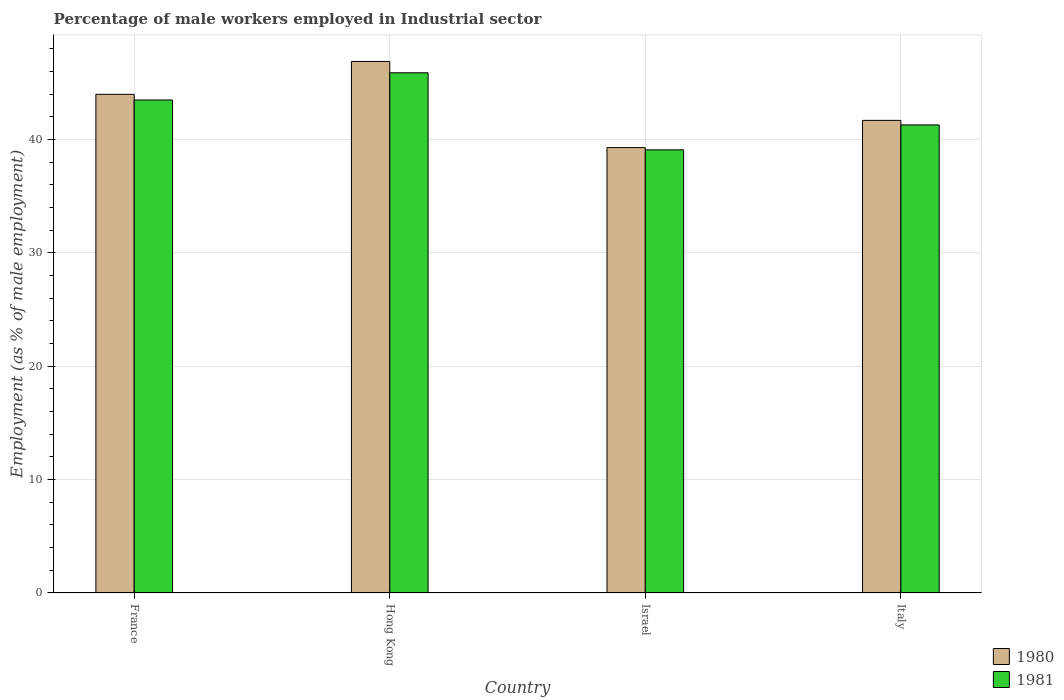How many different coloured bars are there?
Provide a succinct answer. 2. How many groups of bars are there?
Give a very brief answer. 4. Are the number of bars per tick equal to the number of legend labels?
Your response must be concise. Yes. Are the number of bars on each tick of the X-axis equal?
Give a very brief answer. Yes. What is the label of the 4th group of bars from the left?
Give a very brief answer. Italy. What is the percentage of male workers employed in Industrial sector in 1981 in France?
Your response must be concise. 43.5. Across all countries, what is the maximum percentage of male workers employed in Industrial sector in 1980?
Give a very brief answer. 46.9. Across all countries, what is the minimum percentage of male workers employed in Industrial sector in 1981?
Provide a short and direct response. 39.1. In which country was the percentage of male workers employed in Industrial sector in 1980 maximum?
Ensure brevity in your answer.  Hong Kong. In which country was the percentage of male workers employed in Industrial sector in 1981 minimum?
Make the answer very short. Israel. What is the total percentage of male workers employed in Industrial sector in 1981 in the graph?
Give a very brief answer. 169.8. What is the difference between the percentage of male workers employed in Industrial sector in 1980 in France and that in Hong Kong?
Make the answer very short. -2.9. What is the difference between the percentage of male workers employed in Industrial sector in 1980 in France and the percentage of male workers employed in Industrial sector in 1981 in Israel?
Offer a very short reply. 4.9. What is the average percentage of male workers employed in Industrial sector in 1981 per country?
Provide a succinct answer. 42.45. What is the difference between the percentage of male workers employed in Industrial sector of/in 1980 and percentage of male workers employed in Industrial sector of/in 1981 in Italy?
Make the answer very short. 0.4. In how many countries, is the percentage of male workers employed in Industrial sector in 1981 greater than 2 %?
Your response must be concise. 4. What is the ratio of the percentage of male workers employed in Industrial sector in 1980 in Israel to that in Italy?
Offer a very short reply. 0.94. Is the percentage of male workers employed in Industrial sector in 1980 in France less than that in Israel?
Make the answer very short. No. Is the difference between the percentage of male workers employed in Industrial sector in 1980 in Hong Kong and Israel greater than the difference between the percentage of male workers employed in Industrial sector in 1981 in Hong Kong and Israel?
Provide a short and direct response. Yes. What is the difference between the highest and the second highest percentage of male workers employed in Industrial sector in 1980?
Provide a short and direct response. -2.3. What is the difference between the highest and the lowest percentage of male workers employed in Industrial sector in 1981?
Provide a succinct answer. 6.8. What does the 1st bar from the right in France represents?
Make the answer very short. 1981. How many legend labels are there?
Offer a terse response. 2. What is the title of the graph?
Provide a succinct answer. Percentage of male workers employed in Industrial sector. Does "1986" appear as one of the legend labels in the graph?
Make the answer very short. No. What is the label or title of the X-axis?
Your response must be concise. Country. What is the label or title of the Y-axis?
Provide a succinct answer. Employment (as % of male employment). What is the Employment (as % of male employment) of 1981 in France?
Your response must be concise. 43.5. What is the Employment (as % of male employment) in 1980 in Hong Kong?
Offer a very short reply. 46.9. What is the Employment (as % of male employment) of 1981 in Hong Kong?
Provide a succinct answer. 45.9. What is the Employment (as % of male employment) in 1980 in Israel?
Keep it short and to the point. 39.3. What is the Employment (as % of male employment) of 1981 in Israel?
Provide a short and direct response. 39.1. What is the Employment (as % of male employment) in 1980 in Italy?
Make the answer very short. 41.7. What is the Employment (as % of male employment) in 1981 in Italy?
Make the answer very short. 41.3. Across all countries, what is the maximum Employment (as % of male employment) of 1980?
Give a very brief answer. 46.9. Across all countries, what is the maximum Employment (as % of male employment) in 1981?
Provide a succinct answer. 45.9. Across all countries, what is the minimum Employment (as % of male employment) of 1980?
Your answer should be compact. 39.3. Across all countries, what is the minimum Employment (as % of male employment) in 1981?
Make the answer very short. 39.1. What is the total Employment (as % of male employment) in 1980 in the graph?
Give a very brief answer. 171.9. What is the total Employment (as % of male employment) of 1981 in the graph?
Give a very brief answer. 169.8. What is the difference between the Employment (as % of male employment) of 1980 in France and that in Hong Kong?
Offer a very short reply. -2.9. What is the difference between the Employment (as % of male employment) of 1981 in France and that in Hong Kong?
Ensure brevity in your answer.  -2.4. What is the difference between the Employment (as % of male employment) of 1980 in France and that in Israel?
Your answer should be compact. 4.7. What is the difference between the Employment (as % of male employment) of 1981 in France and that in Italy?
Ensure brevity in your answer.  2.2. What is the difference between the Employment (as % of male employment) of 1980 in Hong Kong and that in Israel?
Your answer should be compact. 7.6. What is the difference between the Employment (as % of male employment) of 1980 in Hong Kong and that in Italy?
Provide a short and direct response. 5.2. What is the difference between the Employment (as % of male employment) of 1981 in Hong Kong and that in Italy?
Give a very brief answer. 4.6. What is the difference between the Employment (as % of male employment) of 1980 in France and the Employment (as % of male employment) of 1981 in Israel?
Your answer should be very brief. 4.9. What is the difference between the Employment (as % of male employment) of 1980 in Hong Kong and the Employment (as % of male employment) of 1981 in Israel?
Offer a very short reply. 7.8. What is the difference between the Employment (as % of male employment) in 1980 in Hong Kong and the Employment (as % of male employment) in 1981 in Italy?
Offer a very short reply. 5.6. What is the difference between the Employment (as % of male employment) of 1980 in Israel and the Employment (as % of male employment) of 1981 in Italy?
Your response must be concise. -2. What is the average Employment (as % of male employment) of 1980 per country?
Your answer should be very brief. 42.98. What is the average Employment (as % of male employment) in 1981 per country?
Your response must be concise. 42.45. What is the difference between the Employment (as % of male employment) of 1980 and Employment (as % of male employment) of 1981 in Israel?
Make the answer very short. 0.2. What is the ratio of the Employment (as % of male employment) of 1980 in France to that in Hong Kong?
Offer a very short reply. 0.94. What is the ratio of the Employment (as % of male employment) of 1981 in France to that in Hong Kong?
Offer a terse response. 0.95. What is the ratio of the Employment (as % of male employment) of 1980 in France to that in Israel?
Provide a short and direct response. 1.12. What is the ratio of the Employment (as % of male employment) of 1981 in France to that in Israel?
Your answer should be compact. 1.11. What is the ratio of the Employment (as % of male employment) in 1980 in France to that in Italy?
Make the answer very short. 1.06. What is the ratio of the Employment (as % of male employment) in 1981 in France to that in Italy?
Your response must be concise. 1.05. What is the ratio of the Employment (as % of male employment) in 1980 in Hong Kong to that in Israel?
Offer a very short reply. 1.19. What is the ratio of the Employment (as % of male employment) in 1981 in Hong Kong to that in Israel?
Give a very brief answer. 1.17. What is the ratio of the Employment (as % of male employment) of 1980 in Hong Kong to that in Italy?
Your answer should be very brief. 1.12. What is the ratio of the Employment (as % of male employment) of 1981 in Hong Kong to that in Italy?
Provide a short and direct response. 1.11. What is the ratio of the Employment (as % of male employment) of 1980 in Israel to that in Italy?
Ensure brevity in your answer.  0.94. What is the ratio of the Employment (as % of male employment) of 1981 in Israel to that in Italy?
Make the answer very short. 0.95. What is the difference between the highest and the second highest Employment (as % of male employment) of 1980?
Give a very brief answer. 2.9. What is the difference between the highest and the lowest Employment (as % of male employment) in 1980?
Keep it short and to the point. 7.6. What is the difference between the highest and the lowest Employment (as % of male employment) of 1981?
Ensure brevity in your answer.  6.8. 